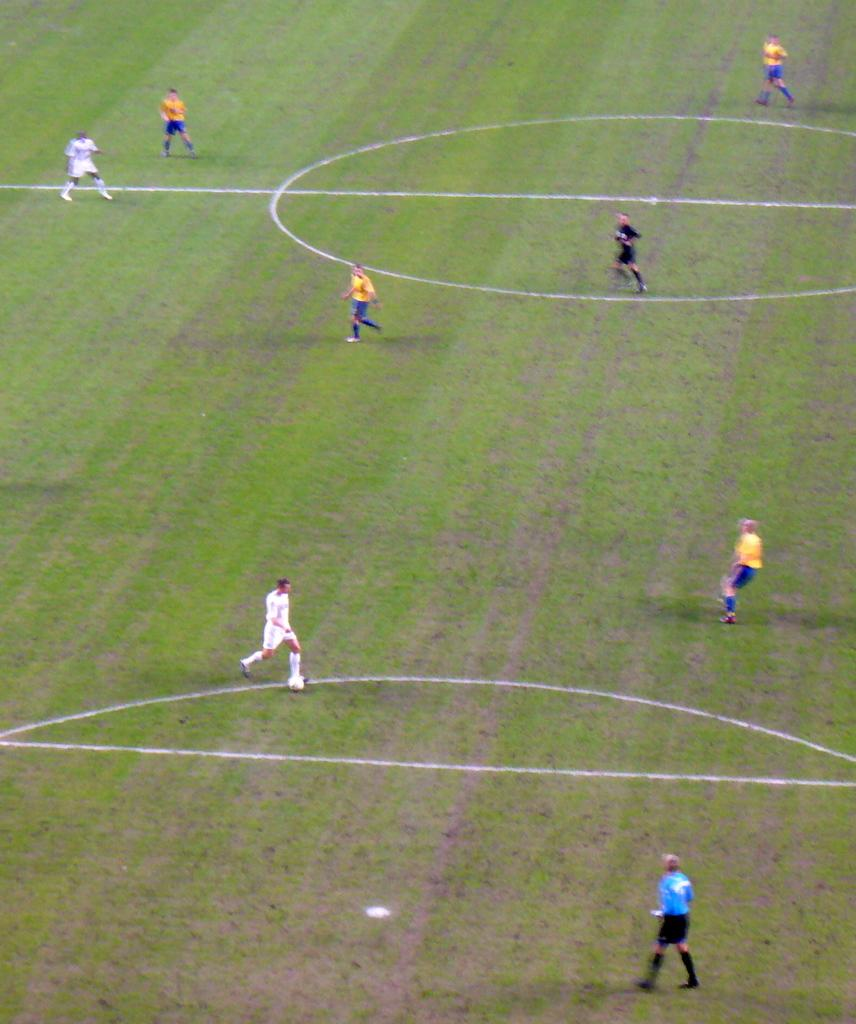How many people are in the image? There is a group of people in the image, but the exact number cannot be determined without more information. What is the position of the people in the image? The people are standing on the ground in the image. What type of steel is used to make the chairs in the image? There are no chairs present in the image, so it is not possible to determine the type of steel used. 